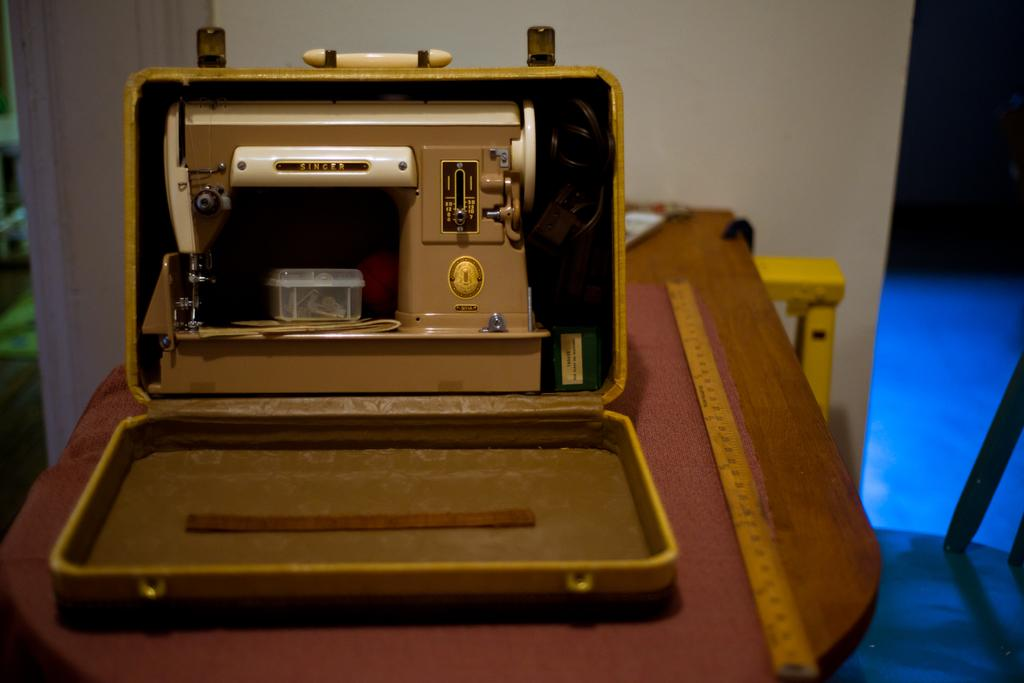What piece of furniture is visible in the image? There is a table in the image. What is located on the table? A sewing machine is present in a box on the table, and there is also a scale. What can be seen in the background of the image? There is a wall in the background of the image. What part of the floor is visible in the image? The floor is visible on the right side of the image. Can you tell me how many eggs are on the table in the image? There are no eggs present on the table in the image. Is there a bath visible in the image? There is no bath present in the image. 